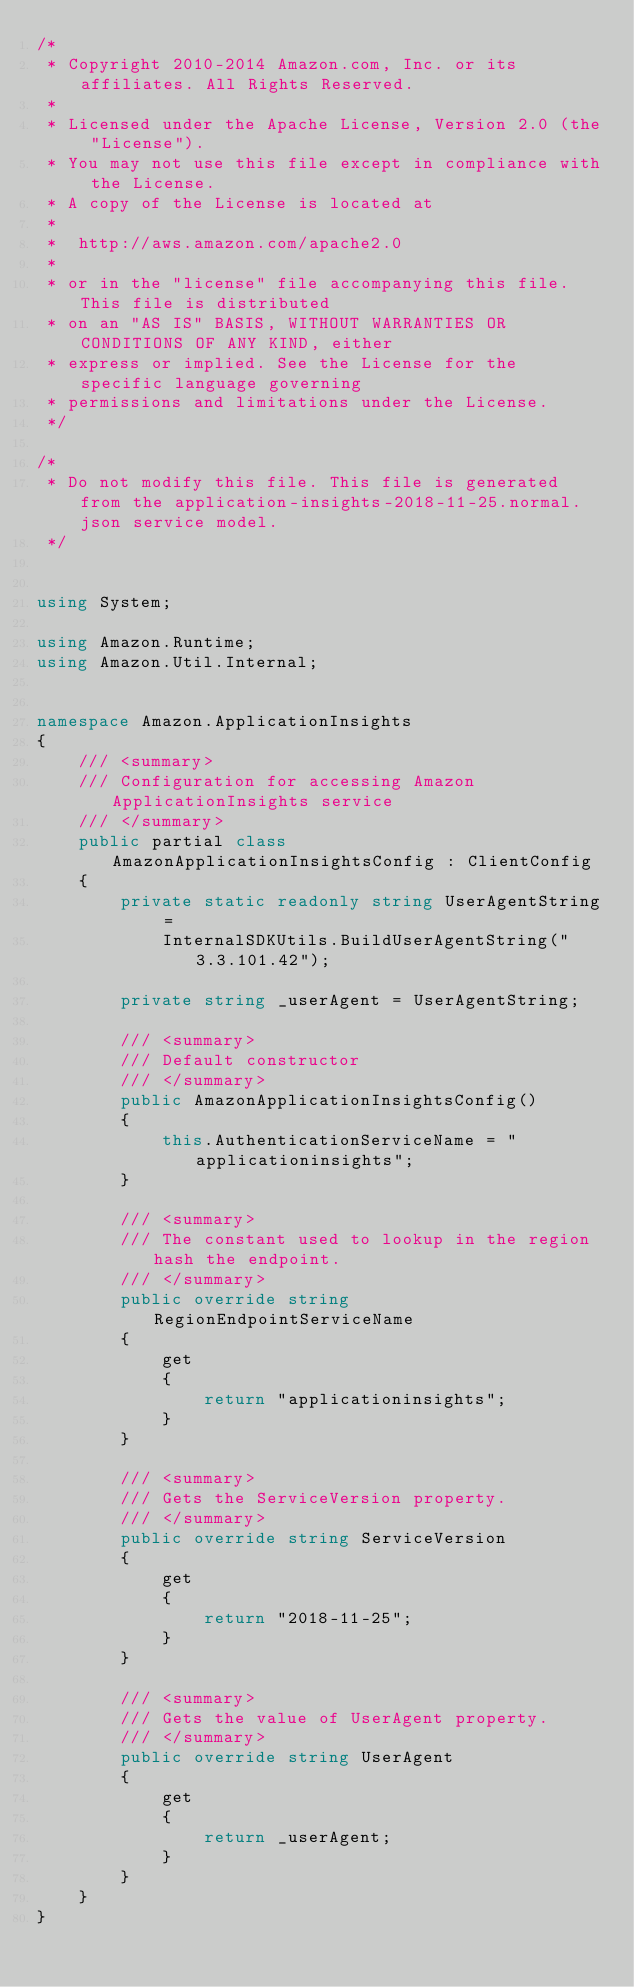Convert code to text. <code><loc_0><loc_0><loc_500><loc_500><_C#_>/*
 * Copyright 2010-2014 Amazon.com, Inc. or its affiliates. All Rights Reserved.
 * 
 * Licensed under the Apache License, Version 2.0 (the "License").
 * You may not use this file except in compliance with the License.
 * A copy of the License is located at
 * 
 *  http://aws.amazon.com/apache2.0
 * 
 * or in the "license" file accompanying this file. This file is distributed
 * on an "AS IS" BASIS, WITHOUT WARRANTIES OR CONDITIONS OF ANY KIND, either
 * express or implied. See the License for the specific language governing
 * permissions and limitations under the License.
 */

/*
 * Do not modify this file. This file is generated from the application-insights-2018-11-25.normal.json service model.
 */


using System;

using Amazon.Runtime;
using Amazon.Util.Internal;


namespace Amazon.ApplicationInsights
{
    /// <summary>
    /// Configuration for accessing Amazon ApplicationInsights service
    /// </summary>
    public partial class AmazonApplicationInsightsConfig : ClientConfig
    {
        private static readonly string UserAgentString =
            InternalSDKUtils.BuildUserAgentString("3.3.101.42");

        private string _userAgent = UserAgentString;

        /// <summary>
        /// Default constructor
        /// </summary>
        public AmazonApplicationInsightsConfig()
        {
            this.AuthenticationServiceName = "applicationinsights";
        }

        /// <summary>
        /// The constant used to lookup in the region hash the endpoint.
        /// </summary>
        public override string RegionEndpointServiceName
        {
            get
            {
                return "applicationinsights";
            }
        }

        /// <summary>
        /// Gets the ServiceVersion property.
        /// </summary>
        public override string ServiceVersion
        {
            get
            {
                return "2018-11-25";
            }
        }

        /// <summary>
        /// Gets the value of UserAgent property.
        /// </summary>
        public override string UserAgent
        {
            get
            {
                return _userAgent;
            }
        }
    }
}</code> 